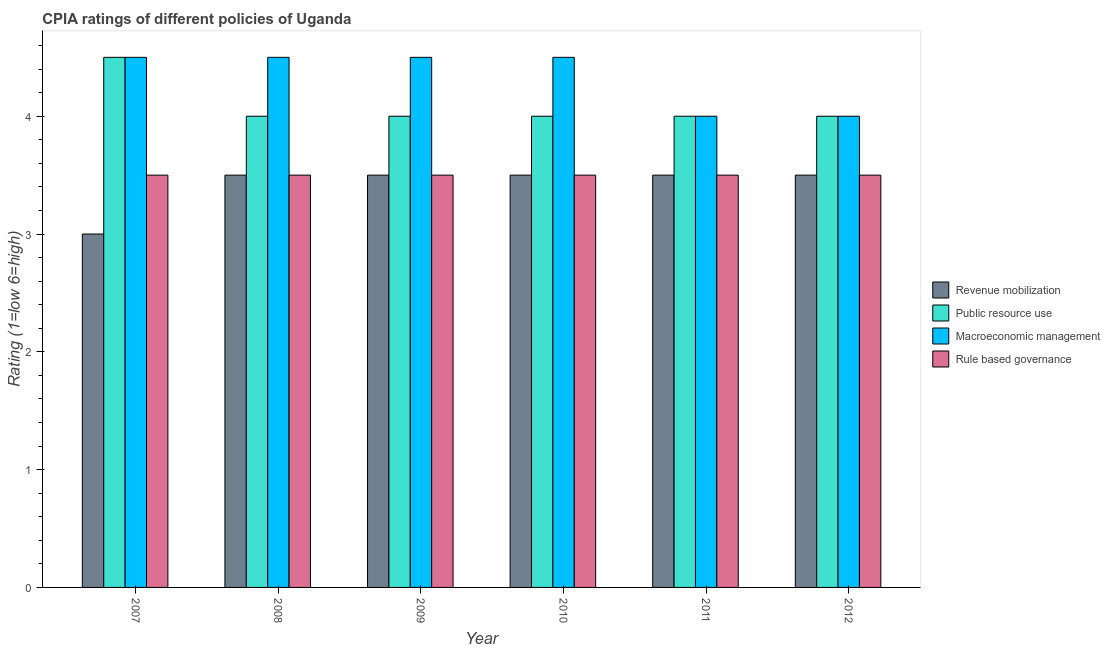How many groups of bars are there?
Provide a short and direct response. 6. Are the number of bars on each tick of the X-axis equal?
Provide a short and direct response. Yes. How many bars are there on the 4th tick from the left?
Provide a short and direct response. 4. What is the label of the 1st group of bars from the left?
Keep it short and to the point. 2007. What is the cpia rating of revenue mobilization in 2011?
Ensure brevity in your answer.  3.5. Across all years, what is the maximum cpia rating of revenue mobilization?
Provide a short and direct response. 3.5. Across all years, what is the minimum cpia rating of macroeconomic management?
Give a very brief answer. 4. In which year was the cpia rating of revenue mobilization minimum?
Keep it short and to the point. 2007. What is the average cpia rating of revenue mobilization per year?
Ensure brevity in your answer.  3.42. In the year 2012, what is the difference between the cpia rating of rule based governance and cpia rating of public resource use?
Offer a very short reply. 0. In how many years, is the cpia rating of macroeconomic management greater than 1.6?
Your response must be concise. 6. In how many years, is the cpia rating of macroeconomic management greater than the average cpia rating of macroeconomic management taken over all years?
Provide a short and direct response. 4. Is it the case that in every year, the sum of the cpia rating of public resource use and cpia rating of rule based governance is greater than the sum of cpia rating of revenue mobilization and cpia rating of macroeconomic management?
Your response must be concise. Yes. What does the 1st bar from the left in 2011 represents?
Your answer should be compact. Revenue mobilization. What does the 1st bar from the right in 2011 represents?
Provide a short and direct response. Rule based governance. How many years are there in the graph?
Ensure brevity in your answer.  6. What is the difference between two consecutive major ticks on the Y-axis?
Your response must be concise. 1. Are the values on the major ticks of Y-axis written in scientific E-notation?
Give a very brief answer. No. Does the graph contain grids?
Your answer should be very brief. No. How many legend labels are there?
Offer a terse response. 4. What is the title of the graph?
Provide a succinct answer. CPIA ratings of different policies of Uganda. What is the label or title of the Y-axis?
Provide a short and direct response. Rating (1=low 6=high). What is the Rating (1=low 6=high) of Revenue mobilization in 2007?
Your response must be concise. 3. What is the Rating (1=low 6=high) in Rule based governance in 2007?
Keep it short and to the point. 3.5. What is the Rating (1=low 6=high) in Revenue mobilization in 2008?
Make the answer very short. 3.5. What is the Rating (1=low 6=high) in Public resource use in 2008?
Provide a short and direct response. 4. What is the Rating (1=low 6=high) of Macroeconomic management in 2008?
Ensure brevity in your answer.  4.5. What is the Rating (1=low 6=high) in Rule based governance in 2008?
Offer a terse response. 3.5. What is the Rating (1=low 6=high) in Revenue mobilization in 2009?
Your answer should be compact. 3.5. What is the Rating (1=low 6=high) in Rule based governance in 2009?
Keep it short and to the point. 3.5. What is the Rating (1=low 6=high) of Rule based governance in 2010?
Your answer should be compact. 3.5. What is the Rating (1=low 6=high) of Revenue mobilization in 2011?
Ensure brevity in your answer.  3.5. What is the Rating (1=low 6=high) of Macroeconomic management in 2011?
Offer a terse response. 4. What is the Rating (1=low 6=high) in Rule based governance in 2011?
Your answer should be compact. 3.5. What is the Rating (1=low 6=high) in Revenue mobilization in 2012?
Provide a short and direct response. 3.5. What is the Rating (1=low 6=high) of Macroeconomic management in 2012?
Give a very brief answer. 4. Across all years, what is the maximum Rating (1=low 6=high) in Revenue mobilization?
Offer a very short reply. 3.5. Across all years, what is the maximum Rating (1=low 6=high) in Macroeconomic management?
Ensure brevity in your answer.  4.5. Across all years, what is the minimum Rating (1=low 6=high) in Revenue mobilization?
Your answer should be very brief. 3. What is the total Rating (1=low 6=high) in Macroeconomic management in the graph?
Give a very brief answer. 26. What is the difference between the Rating (1=low 6=high) of Public resource use in 2007 and that in 2008?
Keep it short and to the point. 0.5. What is the difference between the Rating (1=low 6=high) in Macroeconomic management in 2007 and that in 2009?
Provide a succinct answer. 0. What is the difference between the Rating (1=low 6=high) of Rule based governance in 2007 and that in 2009?
Make the answer very short. 0. What is the difference between the Rating (1=low 6=high) in Public resource use in 2007 and that in 2010?
Keep it short and to the point. 0.5. What is the difference between the Rating (1=low 6=high) of Macroeconomic management in 2007 and that in 2010?
Keep it short and to the point. 0. What is the difference between the Rating (1=low 6=high) in Rule based governance in 2007 and that in 2010?
Your answer should be very brief. 0. What is the difference between the Rating (1=low 6=high) of Public resource use in 2007 and that in 2011?
Ensure brevity in your answer.  0.5. What is the difference between the Rating (1=low 6=high) in Rule based governance in 2007 and that in 2011?
Offer a very short reply. 0. What is the difference between the Rating (1=low 6=high) of Macroeconomic management in 2007 and that in 2012?
Your answer should be very brief. 0.5. What is the difference between the Rating (1=low 6=high) in Rule based governance in 2007 and that in 2012?
Make the answer very short. 0. What is the difference between the Rating (1=low 6=high) in Revenue mobilization in 2008 and that in 2009?
Ensure brevity in your answer.  0. What is the difference between the Rating (1=low 6=high) in Public resource use in 2008 and that in 2009?
Ensure brevity in your answer.  0. What is the difference between the Rating (1=low 6=high) of Public resource use in 2008 and that in 2010?
Make the answer very short. 0. What is the difference between the Rating (1=low 6=high) in Rule based governance in 2008 and that in 2010?
Keep it short and to the point. 0. What is the difference between the Rating (1=low 6=high) of Revenue mobilization in 2008 and that in 2011?
Offer a very short reply. 0. What is the difference between the Rating (1=low 6=high) of Public resource use in 2008 and that in 2011?
Offer a terse response. 0. What is the difference between the Rating (1=low 6=high) of Public resource use in 2008 and that in 2012?
Your response must be concise. 0. What is the difference between the Rating (1=low 6=high) of Macroeconomic management in 2008 and that in 2012?
Provide a succinct answer. 0.5. What is the difference between the Rating (1=low 6=high) in Revenue mobilization in 2009 and that in 2010?
Provide a succinct answer. 0. What is the difference between the Rating (1=low 6=high) in Public resource use in 2009 and that in 2010?
Offer a terse response. 0. What is the difference between the Rating (1=low 6=high) of Macroeconomic management in 2009 and that in 2010?
Offer a terse response. 0. What is the difference between the Rating (1=low 6=high) of Revenue mobilization in 2009 and that in 2011?
Your answer should be very brief. 0. What is the difference between the Rating (1=low 6=high) of Public resource use in 2009 and that in 2011?
Your answer should be compact. 0. What is the difference between the Rating (1=low 6=high) in Revenue mobilization in 2010 and that in 2011?
Offer a very short reply. 0. What is the difference between the Rating (1=low 6=high) in Macroeconomic management in 2010 and that in 2012?
Your answer should be very brief. 0.5. What is the difference between the Rating (1=low 6=high) of Revenue mobilization in 2011 and that in 2012?
Your answer should be compact. 0. What is the difference between the Rating (1=low 6=high) in Public resource use in 2011 and that in 2012?
Your response must be concise. 0. What is the difference between the Rating (1=low 6=high) in Macroeconomic management in 2011 and that in 2012?
Make the answer very short. 0. What is the difference between the Rating (1=low 6=high) of Revenue mobilization in 2007 and the Rating (1=low 6=high) of Macroeconomic management in 2008?
Give a very brief answer. -1.5. What is the difference between the Rating (1=low 6=high) in Revenue mobilization in 2007 and the Rating (1=low 6=high) in Rule based governance in 2008?
Your response must be concise. -0.5. What is the difference between the Rating (1=low 6=high) in Revenue mobilization in 2007 and the Rating (1=low 6=high) in Public resource use in 2009?
Your response must be concise. -1. What is the difference between the Rating (1=low 6=high) in Revenue mobilization in 2007 and the Rating (1=low 6=high) in Macroeconomic management in 2009?
Offer a terse response. -1.5. What is the difference between the Rating (1=low 6=high) of Revenue mobilization in 2007 and the Rating (1=low 6=high) of Rule based governance in 2009?
Provide a succinct answer. -0.5. What is the difference between the Rating (1=low 6=high) of Revenue mobilization in 2007 and the Rating (1=low 6=high) of Rule based governance in 2010?
Your answer should be very brief. -0.5. What is the difference between the Rating (1=low 6=high) in Public resource use in 2007 and the Rating (1=low 6=high) in Rule based governance in 2010?
Offer a terse response. 1. What is the difference between the Rating (1=low 6=high) in Revenue mobilization in 2007 and the Rating (1=low 6=high) in Rule based governance in 2011?
Provide a succinct answer. -0.5. What is the difference between the Rating (1=low 6=high) in Revenue mobilization in 2007 and the Rating (1=low 6=high) in Public resource use in 2012?
Ensure brevity in your answer.  -1. What is the difference between the Rating (1=low 6=high) of Revenue mobilization in 2007 and the Rating (1=low 6=high) of Macroeconomic management in 2012?
Offer a very short reply. -1. What is the difference between the Rating (1=low 6=high) in Revenue mobilization in 2007 and the Rating (1=low 6=high) in Rule based governance in 2012?
Give a very brief answer. -0.5. What is the difference between the Rating (1=low 6=high) of Public resource use in 2007 and the Rating (1=low 6=high) of Macroeconomic management in 2012?
Offer a terse response. 0.5. What is the difference between the Rating (1=low 6=high) of Public resource use in 2007 and the Rating (1=low 6=high) of Rule based governance in 2012?
Your answer should be compact. 1. What is the difference between the Rating (1=low 6=high) in Macroeconomic management in 2007 and the Rating (1=low 6=high) in Rule based governance in 2012?
Offer a terse response. 1. What is the difference between the Rating (1=low 6=high) in Revenue mobilization in 2008 and the Rating (1=low 6=high) in Rule based governance in 2009?
Your answer should be compact. 0. What is the difference between the Rating (1=low 6=high) in Public resource use in 2008 and the Rating (1=low 6=high) in Macroeconomic management in 2009?
Your answer should be compact. -0.5. What is the difference between the Rating (1=low 6=high) in Public resource use in 2008 and the Rating (1=low 6=high) in Rule based governance in 2009?
Keep it short and to the point. 0.5. What is the difference between the Rating (1=low 6=high) of Revenue mobilization in 2008 and the Rating (1=low 6=high) of Public resource use in 2010?
Your response must be concise. -0.5. What is the difference between the Rating (1=low 6=high) of Public resource use in 2008 and the Rating (1=low 6=high) of Macroeconomic management in 2010?
Give a very brief answer. -0.5. What is the difference between the Rating (1=low 6=high) of Revenue mobilization in 2008 and the Rating (1=low 6=high) of Macroeconomic management in 2011?
Your answer should be very brief. -0.5. What is the difference between the Rating (1=low 6=high) of Public resource use in 2008 and the Rating (1=low 6=high) of Macroeconomic management in 2011?
Provide a short and direct response. 0. What is the difference between the Rating (1=low 6=high) in Revenue mobilization in 2008 and the Rating (1=low 6=high) in Public resource use in 2012?
Your response must be concise. -0.5. What is the difference between the Rating (1=low 6=high) in Revenue mobilization in 2008 and the Rating (1=low 6=high) in Macroeconomic management in 2012?
Give a very brief answer. -0.5. What is the difference between the Rating (1=low 6=high) in Revenue mobilization in 2008 and the Rating (1=low 6=high) in Rule based governance in 2012?
Make the answer very short. 0. What is the difference between the Rating (1=low 6=high) in Macroeconomic management in 2008 and the Rating (1=low 6=high) in Rule based governance in 2012?
Your answer should be compact. 1. What is the difference between the Rating (1=low 6=high) in Revenue mobilization in 2009 and the Rating (1=low 6=high) in Public resource use in 2010?
Your answer should be very brief. -0.5. What is the difference between the Rating (1=low 6=high) of Public resource use in 2009 and the Rating (1=low 6=high) of Macroeconomic management in 2010?
Offer a very short reply. -0.5. What is the difference between the Rating (1=low 6=high) in Public resource use in 2009 and the Rating (1=low 6=high) in Rule based governance in 2010?
Give a very brief answer. 0.5. What is the difference between the Rating (1=low 6=high) of Revenue mobilization in 2009 and the Rating (1=low 6=high) of Macroeconomic management in 2012?
Provide a succinct answer. -0.5. What is the difference between the Rating (1=low 6=high) in Revenue mobilization in 2009 and the Rating (1=low 6=high) in Rule based governance in 2012?
Your answer should be compact. 0. What is the difference between the Rating (1=low 6=high) of Macroeconomic management in 2009 and the Rating (1=low 6=high) of Rule based governance in 2012?
Make the answer very short. 1. What is the difference between the Rating (1=low 6=high) in Revenue mobilization in 2010 and the Rating (1=low 6=high) in Public resource use in 2011?
Your answer should be very brief. -0.5. What is the difference between the Rating (1=low 6=high) of Revenue mobilization in 2010 and the Rating (1=low 6=high) of Macroeconomic management in 2011?
Your answer should be compact. -0.5. What is the difference between the Rating (1=low 6=high) in Revenue mobilization in 2010 and the Rating (1=low 6=high) in Rule based governance in 2011?
Give a very brief answer. 0. What is the difference between the Rating (1=low 6=high) in Public resource use in 2010 and the Rating (1=low 6=high) in Macroeconomic management in 2011?
Offer a very short reply. 0. What is the difference between the Rating (1=low 6=high) of Public resource use in 2010 and the Rating (1=low 6=high) of Rule based governance in 2011?
Give a very brief answer. 0.5. What is the difference between the Rating (1=low 6=high) of Macroeconomic management in 2010 and the Rating (1=low 6=high) of Rule based governance in 2011?
Ensure brevity in your answer.  1. What is the difference between the Rating (1=low 6=high) in Revenue mobilization in 2010 and the Rating (1=low 6=high) in Rule based governance in 2012?
Offer a very short reply. 0. What is the difference between the Rating (1=low 6=high) of Revenue mobilization in 2011 and the Rating (1=low 6=high) of Macroeconomic management in 2012?
Your answer should be very brief. -0.5. What is the difference between the Rating (1=low 6=high) of Revenue mobilization in 2011 and the Rating (1=low 6=high) of Rule based governance in 2012?
Keep it short and to the point. 0. What is the difference between the Rating (1=low 6=high) in Macroeconomic management in 2011 and the Rating (1=low 6=high) in Rule based governance in 2012?
Ensure brevity in your answer.  0.5. What is the average Rating (1=low 6=high) of Revenue mobilization per year?
Give a very brief answer. 3.42. What is the average Rating (1=low 6=high) of Public resource use per year?
Ensure brevity in your answer.  4.08. What is the average Rating (1=low 6=high) of Macroeconomic management per year?
Your answer should be compact. 4.33. What is the average Rating (1=low 6=high) in Rule based governance per year?
Provide a short and direct response. 3.5. In the year 2007, what is the difference between the Rating (1=low 6=high) in Revenue mobilization and Rating (1=low 6=high) in Macroeconomic management?
Provide a succinct answer. -1.5. In the year 2007, what is the difference between the Rating (1=low 6=high) in Public resource use and Rating (1=low 6=high) in Rule based governance?
Offer a terse response. 1. In the year 2008, what is the difference between the Rating (1=low 6=high) of Revenue mobilization and Rating (1=low 6=high) of Public resource use?
Provide a short and direct response. -0.5. In the year 2008, what is the difference between the Rating (1=low 6=high) in Public resource use and Rating (1=low 6=high) in Macroeconomic management?
Your answer should be compact. -0.5. In the year 2008, what is the difference between the Rating (1=low 6=high) of Public resource use and Rating (1=low 6=high) of Rule based governance?
Make the answer very short. 0.5. In the year 2008, what is the difference between the Rating (1=low 6=high) of Macroeconomic management and Rating (1=low 6=high) of Rule based governance?
Ensure brevity in your answer.  1. In the year 2009, what is the difference between the Rating (1=low 6=high) of Revenue mobilization and Rating (1=low 6=high) of Rule based governance?
Your response must be concise. 0. In the year 2009, what is the difference between the Rating (1=low 6=high) in Public resource use and Rating (1=low 6=high) in Macroeconomic management?
Offer a very short reply. -0.5. In the year 2010, what is the difference between the Rating (1=low 6=high) in Revenue mobilization and Rating (1=low 6=high) in Rule based governance?
Ensure brevity in your answer.  0. In the year 2010, what is the difference between the Rating (1=low 6=high) in Public resource use and Rating (1=low 6=high) in Macroeconomic management?
Provide a succinct answer. -0.5. In the year 2010, what is the difference between the Rating (1=low 6=high) in Public resource use and Rating (1=low 6=high) in Rule based governance?
Provide a succinct answer. 0.5. In the year 2010, what is the difference between the Rating (1=low 6=high) in Macroeconomic management and Rating (1=low 6=high) in Rule based governance?
Your response must be concise. 1. In the year 2011, what is the difference between the Rating (1=low 6=high) of Revenue mobilization and Rating (1=low 6=high) of Public resource use?
Make the answer very short. -0.5. In the year 2011, what is the difference between the Rating (1=low 6=high) in Revenue mobilization and Rating (1=low 6=high) in Rule based governance?
Offer a very short reply. 0. In the year 2011, what is the difference between the Rating (1=low 6=high) in Public resource use and Rating (1=low 6=high) in Macroeconomic management?
Provide a short and direct response. 0. In the year 2012, what is the difference between the Rating (1=low 6=high) in Revenue mobilization and Rating (1=low 6=high) in Rule based governance?
Provide a succinct answer. 0. In the year 2012, what is the difference between the Rating (1=low 6=high) of Public resource use and Rating (1=low 6=high) of Macroeconomic management?
Give a very brief answer. 0. In the year 2012, what is the difference between the Rating (1=low 6=high) in Public resource use and Rating (1=low 6=high) in Rule based governance?
Offer a terse response. 0.5. What is the ratio of the Rating (1=low 6=high) of Revenue mobilization in 2007 to that in 2009?
Offer a very short reply. 0.86. What is the ratio of the Rating (1=low 6=high) of Public resource use in 2007 to that in 2009?
Offer a very short reply. 1.12. What is the ratio of the Rating (1=low 6=high) in Rule based governance in 2007 to that in 2009?
Your answer should be compact. 1. What is the ratio of the Rating (1=low 6=high) of Revenue mobilization in 2007 to that in 2010?
Offer a very short reply. 0.86. What is the ratio of the Rating (1=low 6=high) in Public resource use in 2007 to that in 2010?
Offer a terse response. 1.12. What is the ratio of the Rating (1=low 6=high) of Rule based governance in 2007 to that in 2010?
Offer a terse response. 1. What is the ratio of the Rating (1=low 6=high) of Macroeconomic management in 2007 to that in 2011?
Your answer should be compact. 1.12. What is the ratio of the Rating (1=low 6=high) in Rule based governance in 2007 to that in 2012?
Keep it short and to the point. 1. What is the ratio of the Rating (1=low 6=high) in Macroeconomic management in 2008 to that in 2009?
Your answer should be compact. 1. What is the ratio of the Rating (1=low 6=high) of Public resource use in 2008 to that in 2010?
Make the answer very short. 1. What is the ratio of the Rating (1=low 6=high) of Macroeconomic management in 2008 to that in 2010?
Your answer should be very brief. 1. What is the ratio of the Rating (1=low 6=high) in Rule based governance in 2008 to that in 2010?
Provide a short and direct response. 1. What is the ratio of the Rating (1=low 6=high) of Revenue mobilization in 2008 to that in 2011?
Provide a short and direct response. 1. What is the ratio of the Rating (1=low 6=high) of Rule based governance in 2008 to that in 2011?
Offer a very short reply. 1. What is the ratio of the Rating (1=low 6=high) in Revenue mobilization in 2008 to that in 2012?
Give a very brief answer. 1. What is the ratio of the Rating (1=low 6=high) in Public resource use in 2008 to that in 2012?
Provide a succinct answer. 1. What is the ratio of the Rating (1=low 6=high) in Revenue mobilization in 2009 to that in 2011?
Your response must be concise. 1. What is the ratio of the Rating (1=low 6=high) of Public resource use in 2009 to that in 2011?
Provide a short and direct response. 1. What is the ratio of the Rating (1=low 6=high) of Revenue mobilization in 2009 to that in 2012?
Provide a succinct answer. 1. What is the ratio of the Rating (1=low 6=high) of Macroeconomic management in 2009 to that in 2012?
Keep it short and to the point. 1.12. What is the ratio of the Rating (1=low 6=high) in Revenue mobilization in 2010 to that in 2011?
Your answer should be compact. 1. What is the ratio of the Rating (1=low 6=high) of Macroeconomic management in 2010 to that in 2011?
Make the answer very short. 1.12. What is the ratio of the Rating (1=low 6=high) in Public resource use in 2010 to that in 2012?
Give a very brief answer. 1. What is the ratio of the Rating (1=low 6=high) of Macroeconomic management in 2010 to that in 2012?
Your answer should be very brief. 1.12. What is the ratio of the Rating (1=low 6=high) of Rule based governance in 2010 to that in 2012?
Offer a very short reply. 1. What is the ratio of the Rating (1=low 6=high) in Revenue mobilization in 2011 to that in 2012?
Ensure brevity in your answer.  1. What is the ratio of the Rating (1=low 6=high) in Public resource use in 2011 to that in 2012?
Provide a succinct answer. 1. What is the ratio of the Rating (1=low 6=high) of Macroeconomic management in 2011 to that in 2012?
Give a very brief answer. 1. What is the ratio of the Rating (1=low 6=high) in Rule based governance in 2011 to that in 2012?
Offer a terse response. 1. What is the difference between the highest and the second highest Rating (1=low 6=high) of Revenue mobilization?
Make the answer very short. 0. What is the difference between the highest and the lowest Rating (1=low 6=high) of Revenue mobilization?
Give a very brief answer. 0.5. What is the difference between the highest and the lowest Rating (1=low 6=high) of Public resource use?
Give a very brief answer. 0.5. What is the difference between the highest and the lowest Rating (1=low 6=high) of Macroeconomic management?
Make the answer very short. 0.5. 